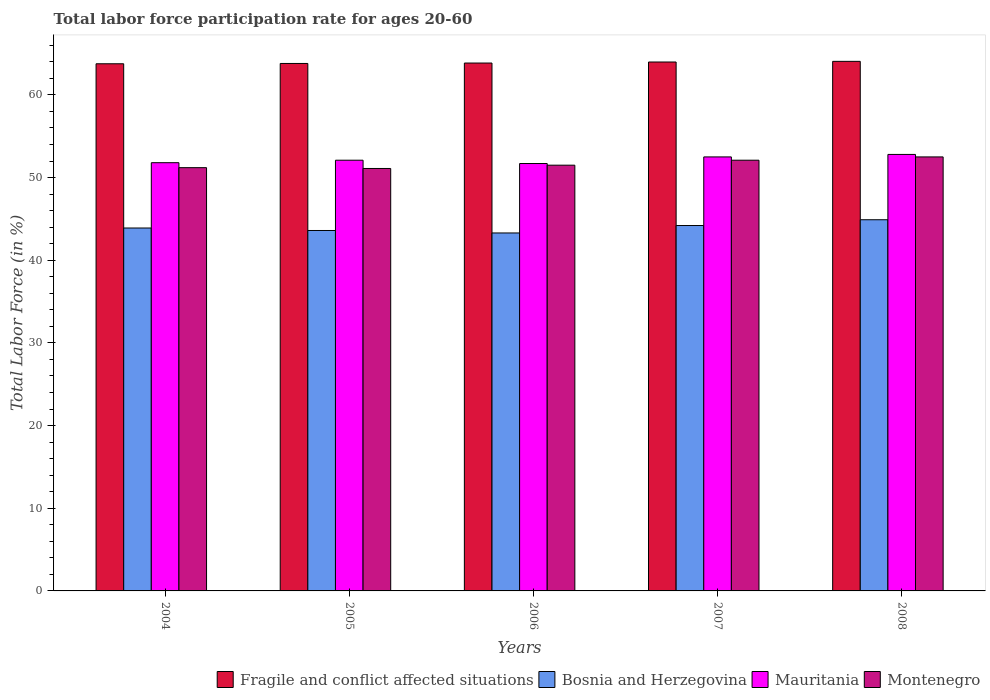How many different coloured bars are there?
Ensure brevity in your answer.  4. How many bars are there on the 3rd tick from the right?
Keep it short and to the point. 4. What is the labor force participation rate in Fragile and conflict affected situations in 2008?
Keep it short and to the point. 64.06. Across all years, what is the maximum labor force participation rate in Montenegro?
Your answer should be very brief. 52.5. Across all years, what is the minimum labor force participation rate in Mauritania?
Ensure brevity in your answer.  51.7. In which year was the labor force participation rate in Mauritania maximum?
Keep it short and to the point. 2008. In which year was the labor force participation rate in Bosnia and Herzegovina minimum?
Make the answer very short. 2006. What is the total labor force participation rate in Montenegro in the graph?
Offer a terse response. 258.4. What is the difference between the labor force participation rate in Fragile and conflict affected situations in 2007 and that in 2008?
Give a very brief answer. -0.08. What is the difference between the labor force participation rate in Bosnia and Herzegovina in 2008 and the labor force participation rate in Fragile and conflict affected situations in 2004?
Your answer should be very brief. -18.87. What is the average labor force participation rate in Bosnia and Herzegovina per year?
Provide a short and direct response. 43.98. In the year 2006, what is the difference between the labor force participation rate in Montenegro and labor force participation rate in Fragile and conflict affected situations?
Keep it short and to the point. -12.36. What is the ratio of the labor force participation rate in Fragile and conflict affected situations in 2007 to that in 2008?
Ensure brevity in your answer.  1. Is the difference between the labor force participation rate in Montenegro in 2004 and 2005 greater than the difference between the labor force participation rate in Fragile and conflict affected situations in 2004 and 2005?
Provide a succinct answer. Yes. What is the difference between the highest and the second highest labor force participation rate in Montenegro?
Your response must be concise. 0.4. What is the difference between the highest and the lowest labor force participation rate in Bosnia and Herzegovina?
Provide a short and direct response. 1.6. What does the 4th bar from the left in 2005 represents?
Your answer should be compact. Montenegro. What does the 1st bar from the right in 2005 represents?
Offer a very short reply. Montenegro. Is it the case that in every year, the sum of the labor force participation rate in Mauritania and labor force participation rate in Bosnia and Herzegovina is greater than the labor force participation rate in Fragile and conflict affected situations?
Offer a very short reply. Yes. How many bars are there?
Provide a succinct answer. 20. Are all the bars in the graph horizontal?
Your response must be concise. No. How many years are there in the graph?
Make the answer very short. 5. What is the difference between two consecutive major ticks on the Y-axis?
Offer a very short reply. 10. Does the graph contain any zero values?
Give a very brief answer. No. How are the legend labels stacked?
Give a very brief answer. Horizontal. What is the title of the graph?
Provide a succinct answer. Total labor force participation rate for ages 20-60. What is the Total Labor Force (in %) of Fragile and conflict affected situations in 2004?
Ensure brevity in your answer.  63.77. What is the Total Labor Force (in %) in Bosnia and Herzegovina in 2004?
Ensure brevity in your answer.  43.9. What is the Total Labor Force (in %) of Mauritania in 2004?
Provide a short and direct response. 51.8. What is the Total Labor Force (in %) in Montenegro in 2004?
Your answer should be compact. 51.2. What is the Total Labor Force (in %) of Fragile and conflict affected situations in 2005?
Offer a very short reply. 63.8. What is the Total Labor Force (in %) in Bosnia and Herzegovina in 2005?
Provide a succinct answer. 43.6. What is the Total Labor Force (in %) in Mauritania in 2005?
Provide a succinct answer. 52.1. What is the Total Labor Force (in %) in Montenegro in 2005?
Your answer should be very brief. 51.1. What is the Total Labor Force (in %) in Fragile and conflict affected situations in 2006?
Keep it short and to the point. 63.86. What is the Total Labor Force (in %) in Bosnia and Herzegovina in 2006?
Your answer should be very brief. 43.3. What is the Total Labor Force (in %) of Mauritania in 2006?
Make the answer very short. 51.7. What is the Total Labor Force (in %) in Montenegro in 2006?
Offer a very short reply. 51.5. What is the Total Labor Force (in %) of Fragile and conflict affected situations in 2007?
Give a very brief answer. 63.98. What is the Total Labor Force (in %) of Bosnia and Herzegovina in 2007?
Ensure brevity in your answer.  44.2. What is the Total Labor Force (in %) in Mauritania in 2007?
Your response must be concise. 52.5. What is the Total Labor Force (in %) in Montenegro in 2007?
Offer a very short reply. 52.1. What is the Total Labor Force (in %) of Fragile and conflict affected situations in 2008?
Your answer should be very brief. 64.06. What is the Total Labor Force (in %) of Bosnia and Herzegovina in 2008?
Offer a terse response. 44.9. What is the Total Labor Force (in %) in Mauritania in 2008?
Your answer should be compact. 52.8. What is the Total Labor Force (in %) of Montenegro in 2008?
Offer a terse response. 52.5. Across all years, what is the maximum Total Labor Force (in %) of Fragile and conflict affected situations?
Your response must be concise. 64.06. Across all years, what is the maximum Total Labor Force (in %) of Bosnia and Herzegovina?
Your answer should be compact. 44.9. Across all years, what is the maximum Total Labor Force (in %) of Mauritania?
Provide a succinct answer. 52.8. Across all years, what is the maximum Total Labor Force (in %) of Montenegro?
Your answer should be compact. 52.5. Across all years, what is the minimum Total Labor Force (in %) of Fragile and conflict affected situations?
Your response must be concise. 63.77. Across all years, what is the minimum Total Labor Force (in %) in Bosnia and Herzegovina?
Offer a very short reply. 43.3. Across all years, what is the minimum Total Labor Force (in %) of Mauritania?
Provide a succinct answer. 51.7. Across all years, what is the minimum Total Labor Force (in %) in Montenegro?
Your response must be concise. 51.1. What is the total Total Labor Force (in %) in Fragile and conflict affected situations in the graph?
Keep it short and to the point. 319.46. What is the total Total Labor Force (in %) of Bosnia and Herzegovina in the graph?
Offer a very short reply. 219.9. What is the total Total Labor Force (in %) in Mauritania in the graph?
Offer a very short reply. 260.9. What is the total Total Labor Force (in %) of Montenegro in the graph?
Keep it short and to the point. 258.4. What is the difference between the Total Labor Force (in %) of Fragile and conflict affected situations in 2004 and that in 2005?
Offer a terse response. -0.04. What is the difference between the Total Labor Force (in %) in Bosnia and Herzegovina in 2004 and that in 2005?
Your answer should be very brief. 0.3. What is the difference between the Total Labor Force (in %) in Mauritania in 2004 and that in 2005?
Offer a very short reply. -0.3. What is the difference between the Total Labor Force (in %) of Montenegro in 2004 and that in 2005?
Make the answer very short. 0.1. What is the difference between the Total Labor Force (in %) in Fragile and conflict affected situations in 2004 and that in 2006?
Ensure brevity in your answer.  -0.09. What is the difference between the Total Labor Force (in %) in Bosnia and Herzegovina in 2004 and that in 2006?
Offer a terse response. 0.6. What is the difference between the Total Labor Force (in %) of Mauritania in 2004 and that in 2006?
Provide a succinct answer. 0.1. What is the difference between the Total Labor Force (in %) in Fragile and conflict affected situations in 2004 and that in 2007?
Offer a terse response. -0.21. What is the difference between the Total Labor Force (in %) of Mauritania in 2004 and that in 2007?
Offer a very short reply. -0.7. What is the difference between the Total Labor Force (in %) of Montenegro in 2004 and that in 2007?
Provide a short and direct response. -0.9. What is the difference between the Total Labor Force (in %) of Fragile and conflict affected situations in 2004 and that in 2008?
Ensure brevity in your answer.  -0.29. What is the difference between the Total Labor Force (in %) in Montenegro in 2004 and that in 2008?
Your response must be concise. -1.3. What is the difference between the Total Labor Force (in %) in Fragile and conflict affected situations in 2005 and that in 2006?
Make the answer very short. -0.05. What is the difference between the Total Labor Force (in %) in Fragile and conflict affected situations in 2005 and that in 2007?
Keep it short and to the point. -0.17. What is the difference between the Total Labor Force (in %) in Mauritania in 2005 and that in 2007?
Your answer should be compact. -0.4. What is the difference between the Total Labor Force (in %) in Montenegro in 2005 and that in 2007?
Provide a short and direct response. -1. What is the difference between the Total Labor Force (in %) in Fragile and conflict affected situations in 2005 and that in 2008?
Your answer should be very brief. -0.25. What is the difference between the Total Labor Force (in %) in Montenegro in 2005 and that in 2008?
Offer a terse response. -1.4. What is the difference between the Total Labor Force (in %) in Fragile and conflict affected situations in 2006 and that in 2007?
Give a very brief answer. -0.12. What is the difference between the Total Labor Force (in %) in Fragile and conflict affected situations in 2006 and that in 2008?
Offer a terse response. -0.2. What is the difference between the Total Labor Force (in %) of Fragile and conflict affected situations in 2007 and that in 2008?
Give a very brief answer. -0.08. What is the difference between the Total Labor Force (in %) in Bosnia and Herzegovina in 2007 and that in 2008?
Offer a terse response. -0.7. What is the difference between the Total Labor Force (in %) of Fragile and conflict affected situations in 2004 and the Total Labor Force (in %) of Bosnia and Herzegovina in 2005?
Keep it short and to the point. 20.17. What is the difference between the Total Labor Force (in %) of Fragile and conflict affected situations in 2004 and the Total Labor Force (in %) of Mauritania in 2005?
Your answer should be very brief. 11.67. What is the difference between the Total Labor Force (in %) in Fragile and conflict affected situations in 2004 and the Total Labor Force (in %) in Montenegro in 2005?
Keep it short and to the point. 12.67. What is the difference between the Total Labor Force (in %) in Bosnia and Herzegovina in 2004 and the Total Labor Force (in %) in Mauritania in 2005?
Your response must be concise. -8.2. What is the difference between the Total Labor Force (in %) in Bosnia and Herzegovina in 2004 and the Total Labor Force (in %) in Montenegro in 2005?
Your response must be concise. -7.2. What is the difference between the Total Labor Force (in %) in Fragile and conflict affected situations in 2004 and the Total Labor Force (in %) in Bosnia and Herzegovina in 2006?
Your answer should be very brief. 20.47. What is the difference between the Total Labor Force (in %) of Fragile and conflict affected situations in 2004 and the Total Labor Force (in %) of Mauritania in 2006?
Keep it short and to the point. 12.07. What is the difference between the Total Labor Force (in %) in Fragile and conflict affected situations in 2004 and the Total Labor Force (in %) in Montenegro in 2006?
Your answer should be very brief. 12.27. What is the difference between the Total Labor Force (in %) of Bosnia and Herzegovina in 2004 and the Total Labor Force (in %) of Montenegro in 2006?
Your answer should be compact. -7.6. What is the difference between the Total Labor Force (in %) of Fragile and conflict affected situations in 2004 and the Total Labor Force (in %) of Bosnia and Herzegovina in 2007?
Your answer should be very brief. 19.57. What is the difference between the Total Labor Force (in %) of Fragile and conflict affected situations in 2004 and the Total Labor Force (in %) of Mauritania in 2007?
Provide a short and direct response. 11.27. What is the difference between the Total Labor Force (in %) in Fragile and conflict affected situations in 2004 and the Total Labor Force (in %) in Montenegro in 2007?
Make the answer very short. 11.67. What is the difference between the Total Labor Force (in %) in Bosnia and Herzegovina in 2004 and the Total Labor Force (in %) in Montenegro in 2007?
Make the answer very short. -8.2. What is the difference between the Total Labor Force (in %) in Fragile and conflict affected situations in 2004 and the Total Labor Force (in %) in Bosnia and Herzegovina in 2008?
Give a very brief answer. 18.87. What is the difference between the Total Labor Force (in %) in Fragile and conflict affected situations in 2004 and the Total Labor Force (in %) in Mauritania in 2008?
Provide a short and direct response. 10.97. What is the difference between the Total Labor Force (in %) of Fragile and conflict affected situations in 2004 and the Total Labor Force (in %) of Montenegro in 2008?
Give a very brief answer. 11.27. What is the difference between the Total Labor Force (in %) in Bosnia and Herzegovina in 2004 and the Total Labor Force (in %) in Mauritania in 2008?
Provide a succinct answer. -8.9. What is the difference between the Total Labor Force (in %) of Bosnia and Herzegovina in 2004 and the Total Labor Force (in %) of Montenegro in 2008?
Give a very brief answer. -8.6. What is the difference between the Total Labor Force (in %) in Fragile and conflict affected situations in 2005 and the Total Labor Force (in %) in Bosnia and Herzegovina in 2006?
Give a very brief answer. 20.5. What is the difference between the Total Labor Force (in %) in Fragile and conflict affected situations in 2005 and the Total Labor Force (in %) in Mauritania in 2006?
Offer a terse response. 12.1. What is the difference between the Total Labor Force (in %) of Fragile and conflict affected situations in 2005 and the Total Labor Force (in %) of Montenegro in 2006?
Give a very brief answer. 12.3. What is the difference between the Total Labor Force (in %) in Bosnia and Herzegovina in 2005 and the Total Labor Force (in %) in Mauritania in 2006?
Your answer should be very brief. -8.1. What is the difference between the Total Labor Force (in %) in Mauritania in 2005 and the Total Labor Force (in %) in Montenegro in 2006?
Provide a succinct answer. 0.6. What is the difference between the Total Labor Force (in %) of Fragile and conflict affected situations in 2005 and the Total Labor Force (in %) of Bosnia and Herzegovina in 2007?
Ensure brevity in your answer.  19.6. What is the difference between the Total Labor Force (in %) of Fragile and conflict affected situations in 2005 and the Total Labor Force (in %) of Mauritania in 2007?
Provide a succinct answer. 11.3. What is the difference between the Total Labor Force (in %) of Fragile and conflict affected situations in 2005 and the Total Labor Force (in %) of Montenegro in 2007?
Ensure brevity in your answer.  11.7. What is the difference between the Total Labor Force (in %) in Bosnia and Herzegovina in 2005 and the Total Labor Force (in %) in Mauritania in 2007?
Offer a terse response. -8.9. What is the difference between the Total Labor Force (in %) in Fragile and conflict affected situations in 2005 and the Total Labor Force (in %) in Bosnia and Herzegovina in 2008?
Offer a terse response. 18.9. What is the difference between the Total Labor Force (in %) in Fragile and conflict affected situations in 2005 and the Total Labor Force (in %) in Mauritania in 2008?
Your response must be concise. 11. What is the difference between the Total Labor Force (in %) in Fragile and conflict affected situations in 2005 and the Total Labor Force (in %) in Montenegro in 2008?
Your answer should be very brief. 11.3. What is the difference between the Total Labor Force (in %) of Bosnia and Herzegovina in 2005 and the Total Labor Force (in %) of Montenegro in 2008?
Your answer should be very brief. -8.9. What is the difference between the Total Labor Force (in %) of Mauritania in 2005 and the Total Labor Force (in %) of Montenegro in 2008?
Provide a succinct answer. -0.4. What is the difference between the Total Labor Force (in %) in Fragile and conflict affected situations in 2006 and the Total Labor Force (in %) in Bosnia and Herzegovina in 2007?
Your answer should be compact. 19.66. What is the difference between the Total Labor Force (in %) of Fragile and conflict affected situations in 2006 and the Total Labor Force (in %) of Mauritania in 2007?
Ensure brevity in your answer.  11.36. What is the difference between the Total Labor Force (in %) in Fragile and conflict affected situations in 2006 and the Total Labor Force (in %) in Montenegro in 2007?
Your answer should be compact. 11.76. What is the difference between the Total Labor Force (in %) of Mauritania in 2006 and the Total Labor Force (in %) of Montenegro in 2007?
Your response must be concise. -0.4. What is the difference between the Total Labor Force (in %) of Fragile and conflict affected situations in 2006 and the Total Labor Force (in %) of Bosnia and Herzegovina in 2008?
Provide a succinct answer. 18.96. What is the difference between the Total Labor Force (in %) in Fragile and conflict affected situations in 2006 and the Total Labor Force (in %) in Mauritania in 2008?
Keep it short and to the point. 11.06. What is the difference between the Total Labor Force (in %) of Fragile and conflict affected situations in 2006 and the Total Labor Force (in %) of Montenegro in 2008?
Ensure brevity in your answer.  11.36. What is the difference between the Total Labor Force (in %) of Bosnia and Herzegovina in 2006 and the Total Labor Force (in %) of Mauritania in 2008?
Ensure brevity in your answer.  -9.5. What is the difference between the Total Labor Force (in %) of Bosnia and Herzegovina in 2006 and the Total Labor Force (in %) of Montenegro in 2008?
Ensure brevity in your answer.  -9.2. What is the difference between the Total Labor Force (in %) of Fragile and conflict affected situations in 2007 and the Total Labor Force (in %) of Bosnia and Herzegovina in 2008?
Provide a succinct answer. 19.08. What is the difference between the Total Labor Force (in %) of Fragile and conflict affected situations in 2007 and the Total Labor Force (in %) of Mauritania in 2008?
Your answer should be compact. 11.18. What is the difference between the Total Labor Force (in %) of Fragile and conflict affected situations in 2007 and the Total Labor Force (in %) of Montenegro in 2008?
Provide a succinct answer. 11.48. What is the difference between the Total Labor Force (in %) of Bosnia and Herzegovina in 2007 and the Total Labor Force (in %) of Montenegro in 2008?
Offer a very short reply. -8.3. What is the difference between the Total Labor Force (in %) of Mauritania in 2007 and the Total Labor Force (in %) of Montenegro in 2008?
Your response must be concise. 0. What is the average Total Labor Force (in %) in Fragile and conflict affected situations per year?
Your answer should be compact. 63.89. What is the average Total Labor Force (in %) of Bosnia and Herzegovina per year?
Your answer should be compact. 43.98. What is the average Total Labor Force (in %) of Mauritania per year?
Your answer should be very brief. 52.18. What is the average Total Labor Force (in %) in Montenegro per year?
Your response must be concise. 51.68. In the year 2004, what is the difference between the Total Labor Force (in %) in Fragile and conflict affected situations and Total Labor Force (in %) in Bosnia and Herzegovina?
Provide a short and direct response. 19.87. In the year 2004, what is the difference between the Total Labor Force (in %) in Fragile and conflict affected situations and Total Labor Force (in %) in Mauritania?
Your answer should be compact. 11.97. In the year 2004, what is the difference between the Total Labor Force (in %) of Fragile and conflict affected situations and Total Labor Force (in %) of Montenegro?
Make the answer very short. 12.57. In the year 2005, what is the difference between the Total Labor Force (in %) in Fragile and conflict affected situations and Total Labor Force (in %) in Bosnia and Herzegovina?
Give a very brief answer. 20.2. In the year 2005, what is the difference between the Total Labor Force (in %) in Fragile and conflict affected situations and Total Labor Force (in %) in Mauritania?
Provide a short and direct response. 11.7. In the year 2005, what is the difference between the Total Labor Force (in %) in Fragile and conflict affected situations and Total Labor Force (in %) in Montenegro?
Your answer should be very brief. 12.7. In the year 2005, what is the difference between the Total Labor Force (in %) in Mauritania and Total Labor Force (in %) in Montenegro?
Give a very brief answer. 1. In the year 2006, what is the difference between the Total Labor Force (in %) in Fragile and conflict affected situations and Total Labor Force (in %) in Bosnia and Herzegovina?
Ensure brevity in your answer.  20.56. In the year 2006, what is the difference between the Total Labor Force (in %) in Fragile and conflict affected situations and Total Labor Force (in %) in Mauritania?
Your response must be concise. 12.16. In the year 2006, what is the difference between the Total Labor Force (in %) of Fragile and conflict affected situations and Total Labor Force (in %) of Montenegro?
Make the answer very short. 12.36. In the year 2006, what is the difference between the Total Labor Force (in %) of Bosnia and Herzegovina and Total Labor Force (in %) of Mauritania?
Give a very brief answer. -8.4. In the year 2007, what is the difference between the Total Labor Force (in %) in Fragile and conflict affected situations and Total Labor Force (in %) in Bosnia and Herzegovina?
Provide a short and direct response. 19.78. In the year 2007, what is the difference between the Total Labor Force (in %) of Fragile and conflict affected situations and Total Labor Force (in %) of Mauritania?
Your answer should be very brief. 11.48. In the year 2007, what is the difference between the Total Labor Force (in %) in Fragile and conflict affected situations and Total Labor Force (in %) in Montenegro?
Offer a terse response. 11.88. In the year 2007, what is the difference between the Total Labor Force (in %) in Bosnia and Herzegovina and Total Labor Force (in %) in Mauritania?
Your answer should be very brief. -8.3. In the year 2008, what is the difference between the Total Labor Force (in %) in Fragile and conflict affected situations and Total Labor Force (in %) in Bosnia and Herzegovina?
Give a very brief answer. 19.16. In the year 2008, what is the difference between the Total Labor Force (in %) of Fragile and conflict affected situations and Total Labor Force (in %) of Mauritania?
Offer a terse response. 11.26. In the year 2008, what is the difference between the Total Labor Force (in %) of Fragile and conflict affected situations and Total Labor Force (in %) of Montenegro?
Keep it short and to the point. 11.56. In the year 2008, what is the difference between the Total Labor Force (in %) of Bosnia and Herzegovina and Total Labor Force (in %) of Montenegro?
Your answer should be compact. -7.6. What is the ratio of the Total Labor Force (in %) in Fragile and conflict affected situations in 2004 to that in 2005?
Your answer should be compact. 1. What is the ratio of the Total Labor Force (in %) of Bosnia and Herzegovina in 2004 to that in 2005?
Offer a very short reply. 1.01. What is the ratio of the Total Labor Force (in %) of Bosnia and Herzegovina in 2004 to that in 2006?
Your answer should be compact. 1.01. What is the ratio of the Total Labor Force (in %) in Mauritania in 2004 to that in 2006?
Offer a very short reply. 1. What is the ratio of the Total Labor Force (in %) of Bosnia and Herzegovina in 2004 to that in 2007?
Ensure brevity in your answer.  0.99. What is the ratio of the Total Labor Force (in %) in Mauritania in 2004 to that in 2007?
Provide a short and direct response. 0.99. What is the ratio of the Total Labor Force (in %) of Montenegro in 2004 to that in 2007?
Offer a very short reply. 0.98. What is the ratio of the Total Labor Force (in %) of Fragile and conflict affected situations in 2004 to that in 2008?
Give a very brief answer. 1. What is the ratio of the Total Labor Force (in %) in Bosnia and Herzegovina in 2004 to that in 2008?
Make the answer very short. 0.98. What is the ratio of the Total Labor Force (in %) in Mauritania in 2004 to that in 2008?
Your answer should be compact. 0.98. What is the ratio of the Total Labor Force (in %) in Montenegro in 2004 to that in 2008?
Offer a very short reply. 0.98. What is the ratio of the Total Labor Force (in %) in Fragile and conflict affected situations in 2005 to that in 2006?
Make the answer very short. 1. What is the ratio of the Total Labor Force (in %) of Mauritania in 2005 to that in 2006?
Your answer should be compact. 1.01. What is the ratio of the Total Labor Force (in %) in Fragile and conflict affected situations in 2005 to that in 2007?
Keep it short and to the point. 1. What is the ratio of the Total Labor Force (in %) in Bosnia and Herzegovina in 2005 to that in 2007?
Offer a terse response. 0.99. What is the ratio of the Total Labor Force (in %) of Montenegro in 2005 to that in 2007?
Give a very brief answer. 0.98. What is the ratio of the Total Labor Force (in %) of Mauritania in 2005 to that in 2008?
Your response must be concise. 0.99. What is the ratio of the Total Labor Force (in %) in Montenegro in 2005 to that in 2008?
Make the answer very short. 0.97. What is the ratio of the Total Labor Force (in %) of Bosnia and Herzegovina in 2006 to that in 2007?
Give a very brief answer. 0.98. What is the ratio of the Total Labor Force (in %) of Mauritania in 2006 to that in 2007?
Offer a terse response. 0.98. What is the ratio of the Total Labor Force (in %) of Bosnia and Herzegovina in 2006 to that in 2008?
Provide a succinct answer. 0.96. What is the ratio of the Total Labor Force (in %) of Mauritania in 2006 to that in 2008?
Your answer should be compact. 0.98. What is the ratio of the Total Labor Force (in %) of Fragile and conflict affected situations in 2007 to that in 2008?
Give a very brief answer. 1. What is the ratio of the Total Labor Force (in %) of Bosnia and Herzegovina in 2007 to that in 2008?
Provide a succinct answer. 0.98. What is the ratio of the Total Labor Force (in %) in Montenegro in 2007 to that in 2008?
Make the answer very short. 0.99. What is the difference between the highest and the second highest Total Labor Force (in %) of Fragile and conflict affected situations?
Make the answer very short. 0.08. What is the difference between the highest and the second highest Total Labor Force (in %) of Bosnia and Herzegovina?
Keep it short and to the point. 0.7. What is the difference between the highest and the second highest Total Labor Force (in %) in Mauritania?
Keep it short and to the point. 0.3. What is the difference between the highest and the second highest Total Labor Force (in %) of Montenegro?
Provide a short and direct response. 0.4. What is the difference between the highest and the lowest Total Labor Force (in %) in Fragile and conflict affected situations?
Ensure brevity in your answer.  0.29. What is the difference between the highest and the lowest Total Labor Force (in %) of Montenegro?
Offer a terse response. 1.4. 